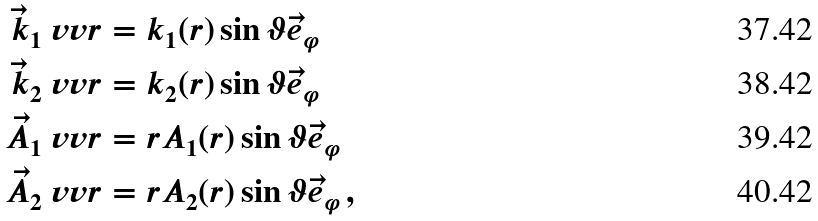Convert formula to latex. <formula><loc_0><loc_0><loc_500><loc_500>\vec { k } _ { 1 } \ v v r & = k _ { 1 } ( r ) \sin \vartheta \vec { e } _ { \varphi } \\ \vec { k } _ { 2 } \ v v r & = k _ { 2 } ( r ) \sin \vartheta \vec { e } _ { \varphi } \\ \vec { A } _ { 1 } \ v v r & = r A _ { 1 } ( r ) \sin \vartheta \vec { e } _ { \varphi } \\ \vec { A } _ { 2 } \ v v r & = r A _ { 2 } ( r ) \sin \vartheta \vec { e } _ { \varphi } \, ,</formula> 